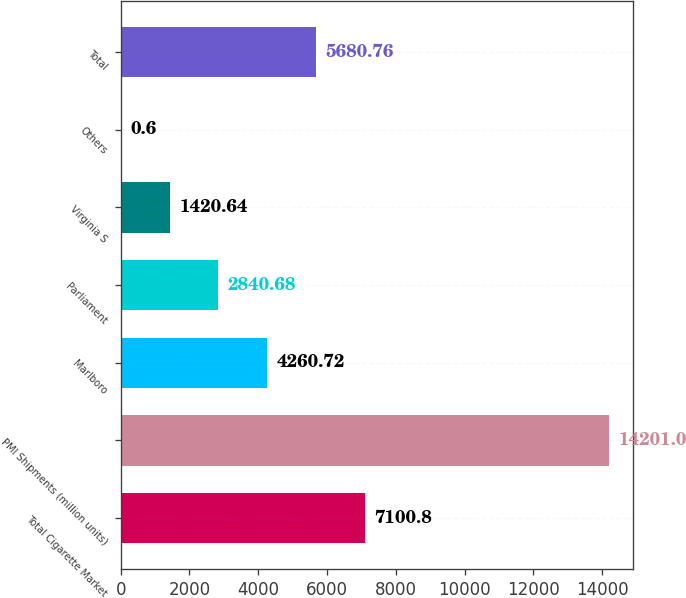Convert chart. <chart><loc_0><loc_0><loc_500><loc_500><bar_chart><fcel>Total Cigarette Market<fcel>PMI Shipments (million units)<fcel>Marlboro<fcel>Parliament<fcel>Virginia S<fcel>Others<fcel>Total<nl><fcel>7100.8<fcel>14201<fcel>4260.72<fcel>2840.68<fcel>1420.64<fcel>0.6<fcel>5680.76<nl></chart> 